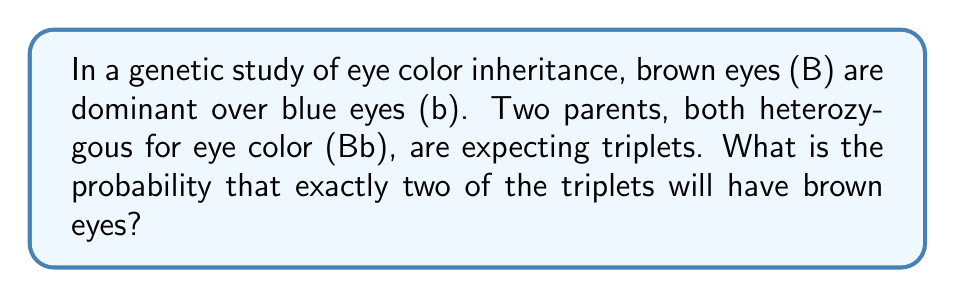Help me with this question. To solve this problem, we'll use a combination of Punnett squares and combinatorics. Let's break it down step-by-step:

1. First, let's create a Punnett square for the parents (both Bb):

   $$
   \begin{array}{c|cc}
     & B & b \\
   \hline
   B & BB & Bb \\
   b & Bb & bb
   \end{array}
   $$

2. From the Punnett square, we can see that:
   - The probability of a child having brown eyes (BB or Bb) is $\frac{3}{4}$
   - The probability of a child having blue eyes (bb) is $\frac{1}{4}$

3. Now, we need to calculate the probability of exactly 2 out of 3 triplets having brown eyes. This is a binomial probability problem.

4. We can use the binomial probability formula:

   $$ P(X = k) = \binom{n}{k} p^k (1-p)^{n-k} $$

   Where:
   - $n$ is the number of trials (3 in this case)
   - $k$ is the number of successes (2 in this case)
   - $p$ is the probability of success on each trial ($\frac{3}{4}$ in this case)

5. Plugging in our values:

   $$ P(X = 2) = \binom{3}{2} (\frac{3}{4})^2 (\frac{1}{4})^{3-2} $$

6. Calculate the binomial coefficient:

   $$ \binom{3}{2} = \frac{3!}{2!(3-2)!} = \frac{3 \cdot 2 \cdot 1}{(2 \cdot 1)(1)} = 3 $$

7. Now we can compute the final probability:

   $$ P(X = 2) = 3 \cdot (\frac{3}{4})^2 \cdot (\frac{1}{4})^1 = 3 \cdot \frac{9}{16} \cdot \frac{1}{4} = \frac{27}{64} $$
Answer: The probability that exactly two of the triplets will have brown eyes is $\frac{27}{64}$ or approximately 0.4219 (42.19%). 